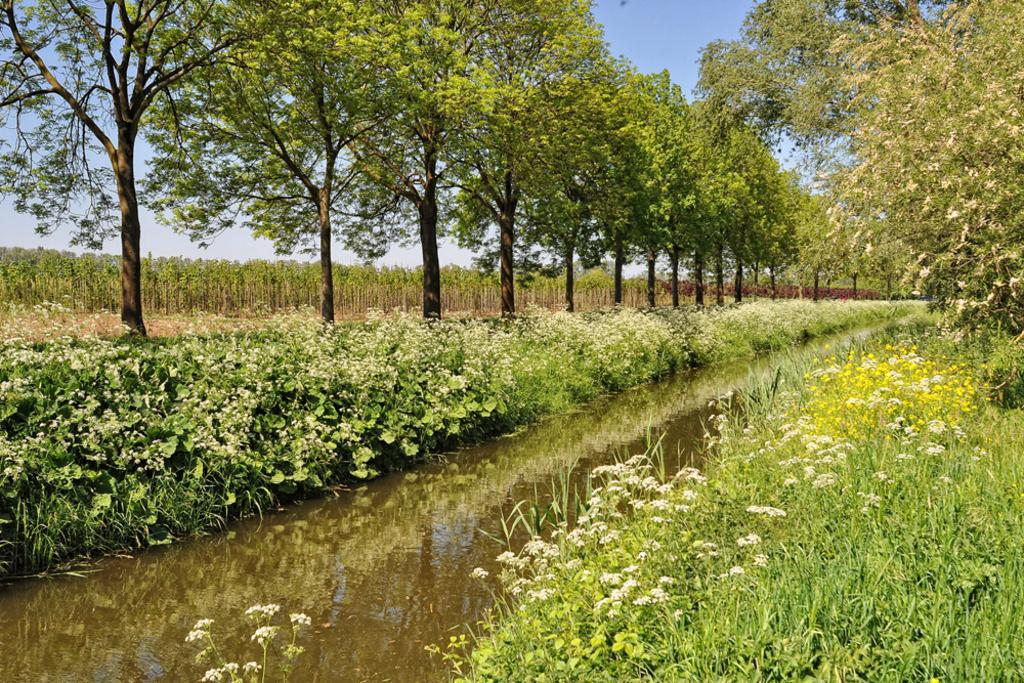What type of vegetation is present in the image? There are flowers and grass in the image. What can be seen in the water in the image? The image only shows water, but no specific details about what is in the water. What is located on the right side of the image? There are trees on the right side of the image. What type of landscape can be seen in the background of the image? There is farmland in the left background of the image. What is visible at the top of the image? The sky is visible at the top of the image. What type of ice is being used to build a prison in the image? There is no ice or prison present in the image. How many thumbs can be seen interacting with the flowers in the image? There is no thumb or interaction with the flowers visible in the image. 